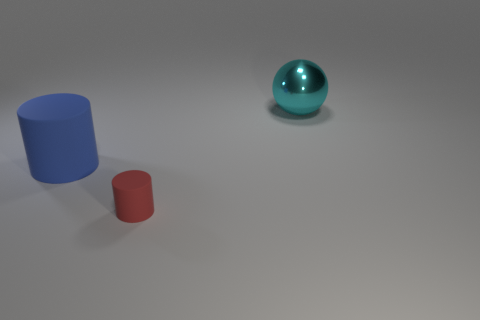How many small red matte cylinders are left of the large thing behind the blue matte thing?
Keep it short and to the point. 1. Is there anything else of the same color as the large cylinder?
Provide a succinct answer. No. What number of objects are matte cylinders or big things that are on the left side of the cyan metal thing?
Your answer should be compact. 2. The cylinder that is in front of the rubber thing that is left of the object in front of the big matte thing is made of what material?
Ensure brevity in your answer.  Rubber. There is a cylinder that is the same material as the blue object; what size is it?
Offer a terse response. Small. What color is the matte cylinder in front of the cylinder that is on the left side of the small red rubber cylinder?
Give a very brief answer. Red. What number of cyan objects have the same material as the large blue cylinder?
Give a very brief answer. 0. How many rubber things are either small yellow blocks or balls?
Your answer should be compact. 0. There is a cyan ball that is the same size as the blue rubber cylinder; what is it made of?
Offer a very short reply. Metal. Is there a object made of the same material as the big blue cylinder?
Provide a succinct answer. Yes. 